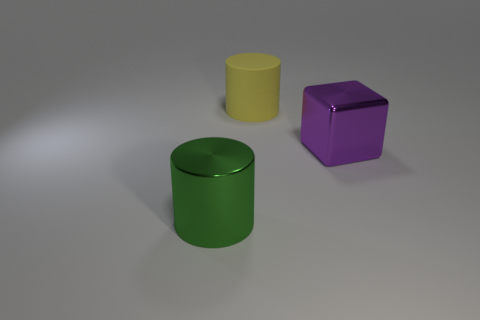Add 1 large yellow matte things. How many objects exist? 4 Subtract all cubes. How many objects are left? 2 Add 3 tiny cyan matte blocks. How many tiny cyan matte blocks exist? 3 Subtract 0 gray blocks. How many objects are left? 3 Subtract all large purple metal objects. Subtract all big yellow objects. How many objects are left? 1 Add 1 big green metal cylinders. How many big green metal cylinders are left? 2 